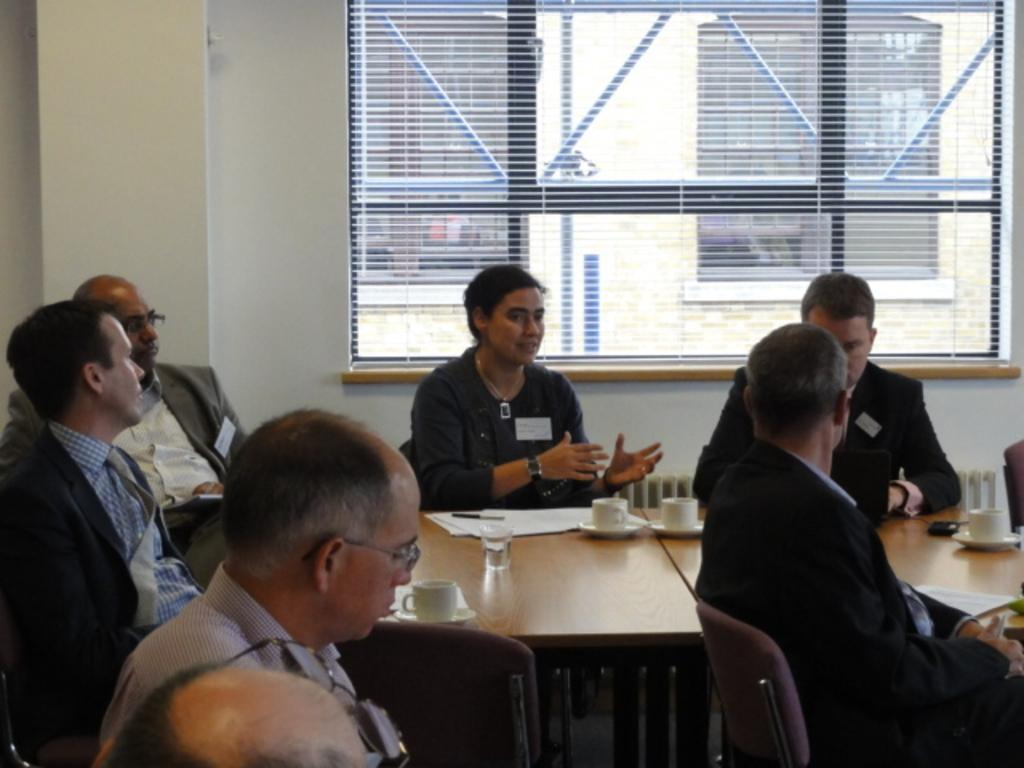What is the main subject of the image? The main subject of the image is a group of people. What are the people in the image doing? The people are sitting around a table. What items can be seen on the table in the image? There are coffee cups and water glasses on the table. Can you tell me how many rocks are on the table in the image? There are no rocks present on the table in the image. What type of leaf is being used as a napkin by one of the people in the image? There are no leaves present in the image, and no one is using a leaf as a napkin. 